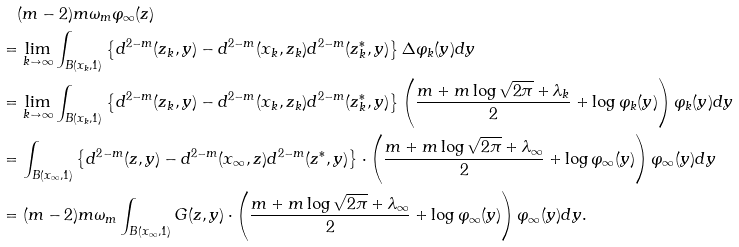Convert formula to latex. <formula><loc_0><loc_0><loc_500><loc_500>& \quad ( m - 2 ) m \omega _ { m } \varphi _ { \infty } ( z ) \\ & = \lim _ { k \to \infty } \int _ { B ( x _ { k } , 1 ) } \left \{ d ^ { 2 - m } ( z _ { k } , y ) - d ^ { 2 - m } ( x _ { k } , z _ { k } ) d ^ { 2 - m } ( z _ { k } ^ { * } , y ) \right \} \Delta \varphi _ { k } ( y ) d y \\ & = \lim _ { k \to \infty } \int _ { B ( x _ { k } , 1 ) } \left \{ d ^ { 2 - m } ( z _ { k } , y ) - d ^ { 2 - m } ( x _ { k } , z _ { k } ) d ^ { 2 - m } ( z _ { k } ^ { * } , y ) \right \} \left ( \frac { m + m \log \sqrt { 2 \pi } + \lambda _ { k } } { 2 } + \log \varphi _ { k } ( y ) \right ) \varphi _ { k } ( y ) d y \\ & = \int _ { B ( x _ { \infty } , 1 ) } \left \{ d ^ { 2 - m } ( z , y ) - d ^ { 2 - m } ( x _ { \infty } , z ) d ^ { 2 - m } ( z ^ { * } , y ) \right \} \cdot \left ( \frac { m + m \log \sqrt { 2 \pi } + \lambda _ { \infty } } { 2 } + \log \varphi _ { \infty } ( y ) \right ) \varphi _ { \infty } ( y ) d y \\ & = ( m - 2 ) m \omega _ { m } \int _ { B ( x _ { \infty } , 1 ) } G ( z , y ) \cdot \left ( \frac { m + m \log \sqrt { 2 \pi } + \lambda _ { \infty } } { 2 } + \log \varphi _ { \infty } ( y ) \right ) \varphi _ { \infty } ( y ) d y .</formula> 